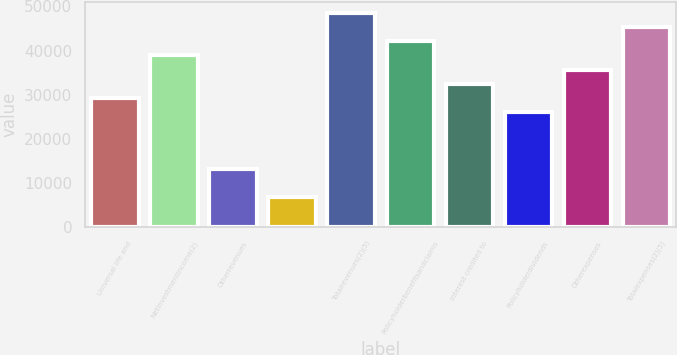Convert chart. <chart><loc_0><loc_0><loc_500><loc_500><bar_chart><fcel>Universal life and<fcel>Netinvestmentincome(2)<fcel>Otherrevenues<fcel>Unnamed: 3<fcel>Totalrevenues(2)(5)<fcel>Policyholderbenefitsandclaims<fcel>Interest credited to<fcel>Policyholderdividends<fcel>Otherexpenses<fcel>Totalexpenses(2)(5)<nl><fcel>29270.2<fcel>38887.6<fcel>13241.2<fcel>6829.6<fcel>48505<fcel>42093.4<fcel>32476<fcel>26064.4<fcel>35681.8<fcel>45299.2<nl></chart> 